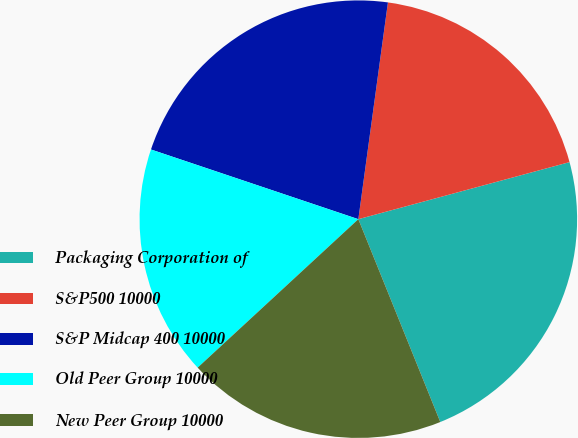Convert chart. <chart><loc_0><loc_0><loc_500><loc_500><pie_chart><fcel>Packaging Corporation of<fcel>S&P500 10000<fcel>S&P Midcap 400 10000<fcel>Old Peer Group 10000<fcel>New Peer Group 10000<nl><fcel>23.09%<fcel>18.64%<fcel>22.0%<fcel>17.03%<fcel>19.24%<nl></chart> 